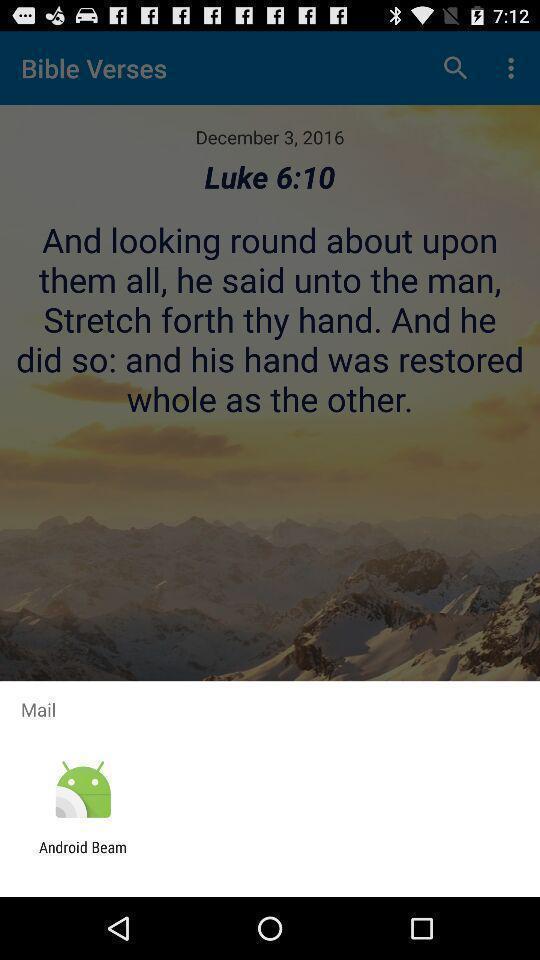Give me a narrative description of this picture. Pop up showing to share. 